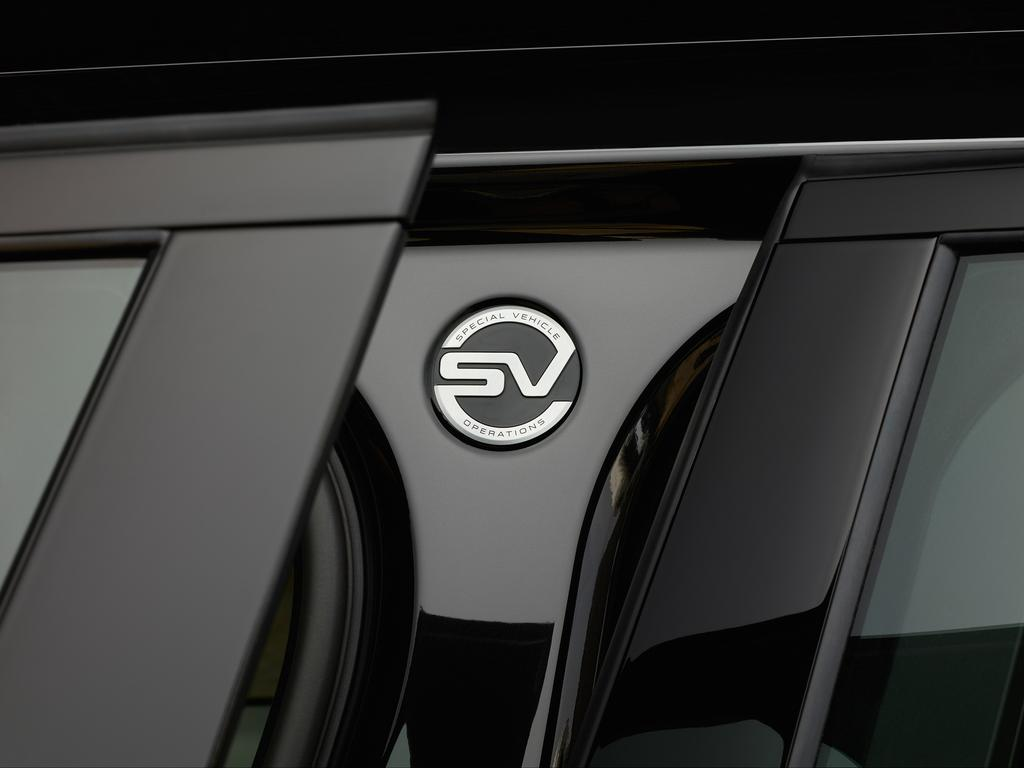What is present on the car in the image? There is a logo on the car. What feature of the car allows people to enter and exit? There are doors on the car. What type of hat is the car wearing in the image? There is no hat present on the car in the image. In which town is the car located in the image? The image does not provide information about the town where the car is located. 